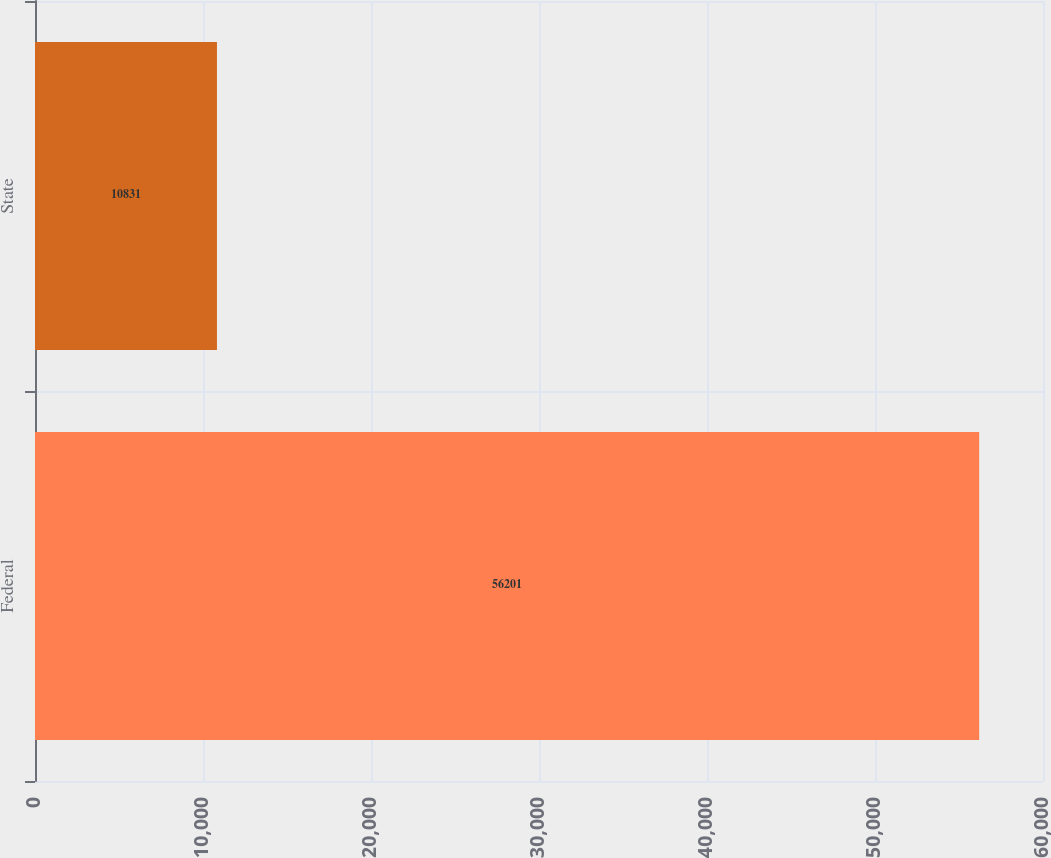Convert chart. <chart><loc_0><loc_0><loc_500><loc_500><bar_chart><fcel>Federal<fcel>State<nl><fcel>56201<fcel>10831<nl></chart> 